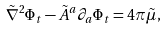<formula> <loc_0><loc_0><loc_500><loc_500>\tilde { \nabla } ^ { 2 } \Phi _ { t } - \tilde { A } ^ { a } \partial _ { a } \Phi _ { t } = 4 \pi \tilde { \mu } ,</formula> 